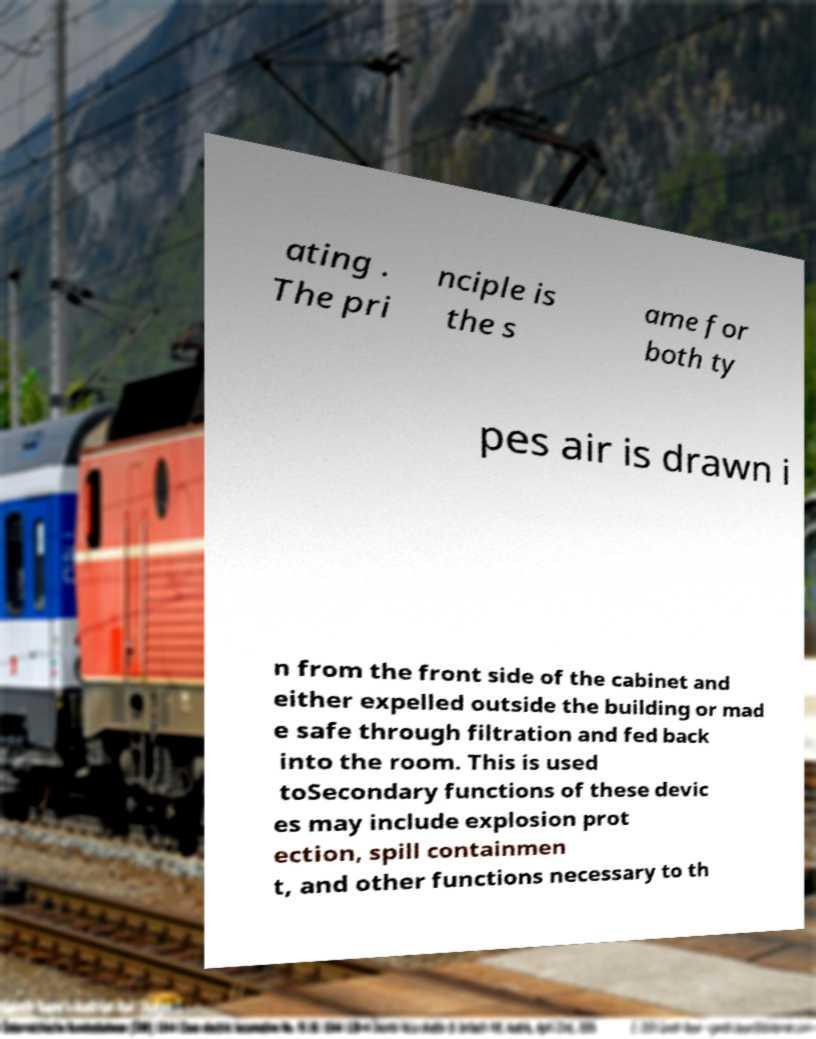Can you accurately transcribe the text from the provided image for me? ating . The pri nciple is the s ame for both ty pes air is drawn i n from the front side of the cabinet and either expelled outside the building or mad e safe through filtration and fed back into the room. This is used toSecondary functions of these devic es may include explosion prot ection, spill containmen t, and other functions necessary to th 